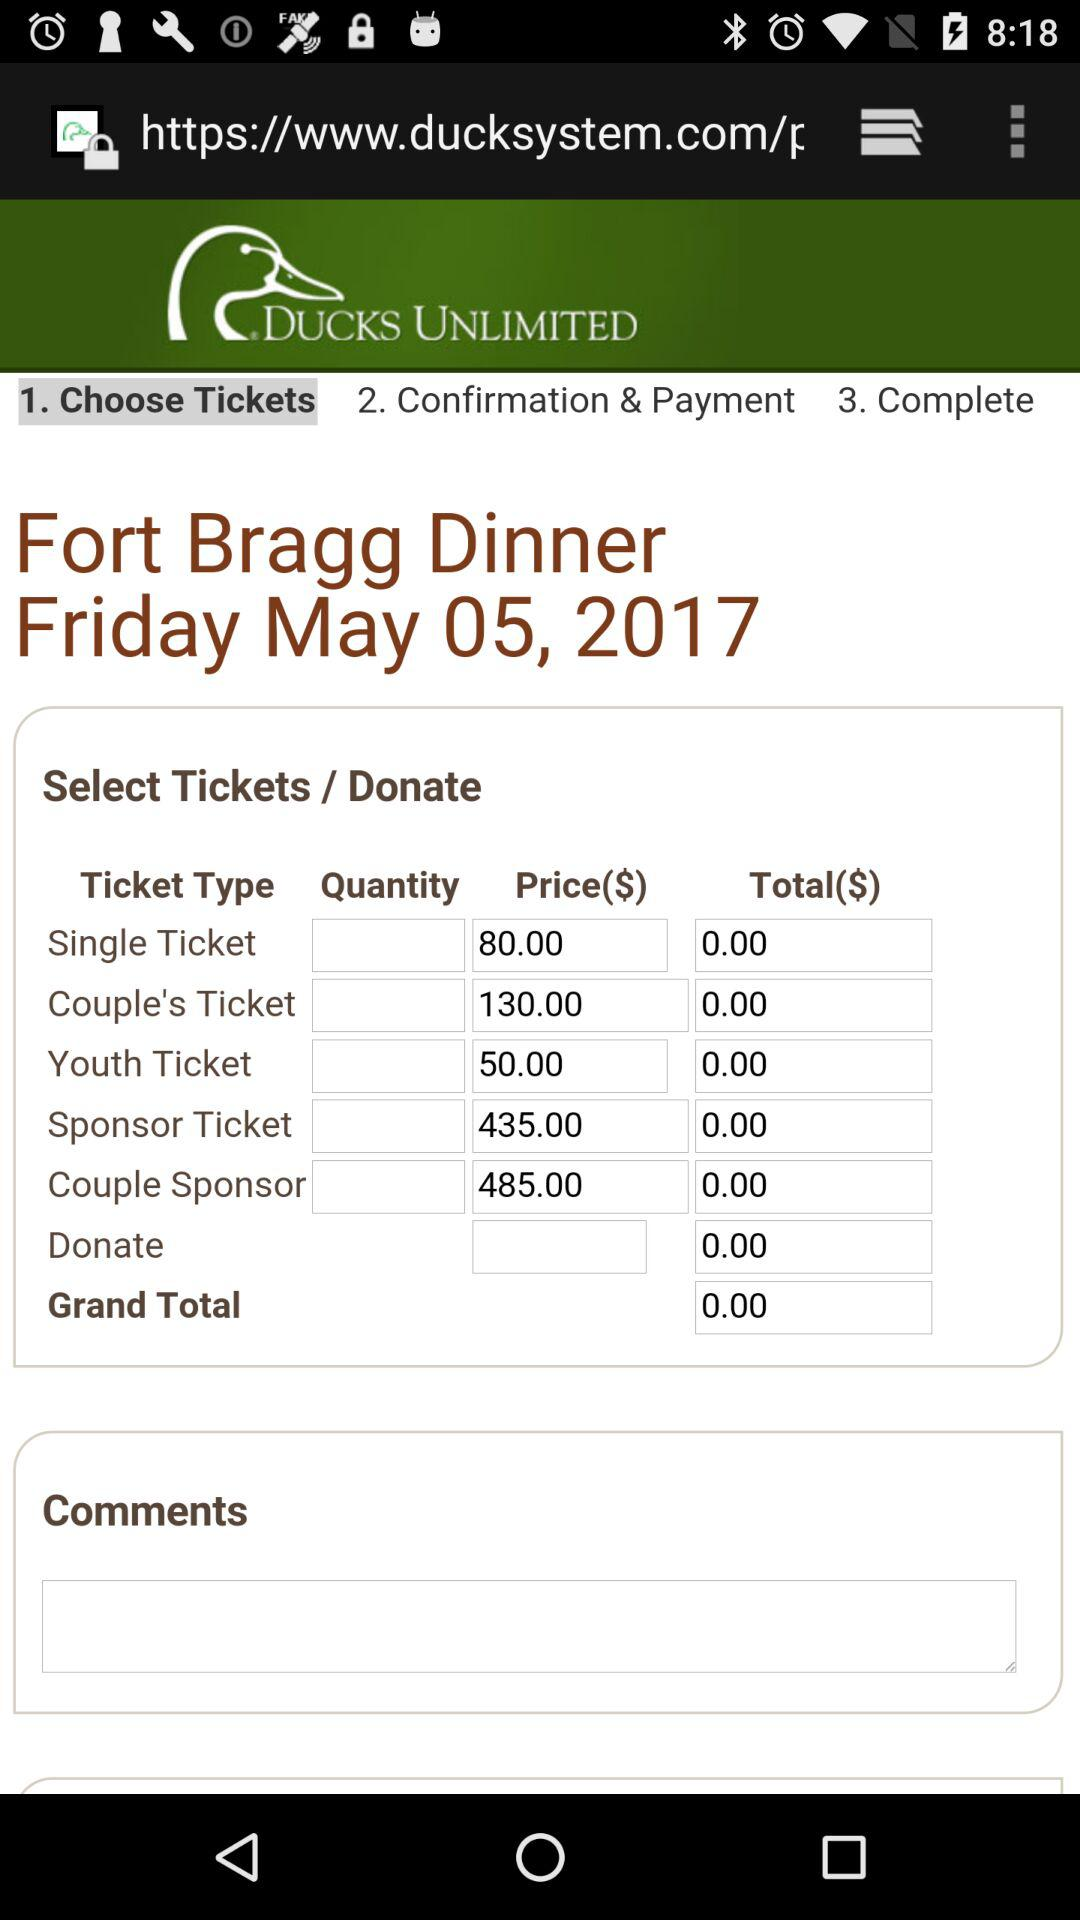What is the price for the "Single Ticket"? The price is $80. 